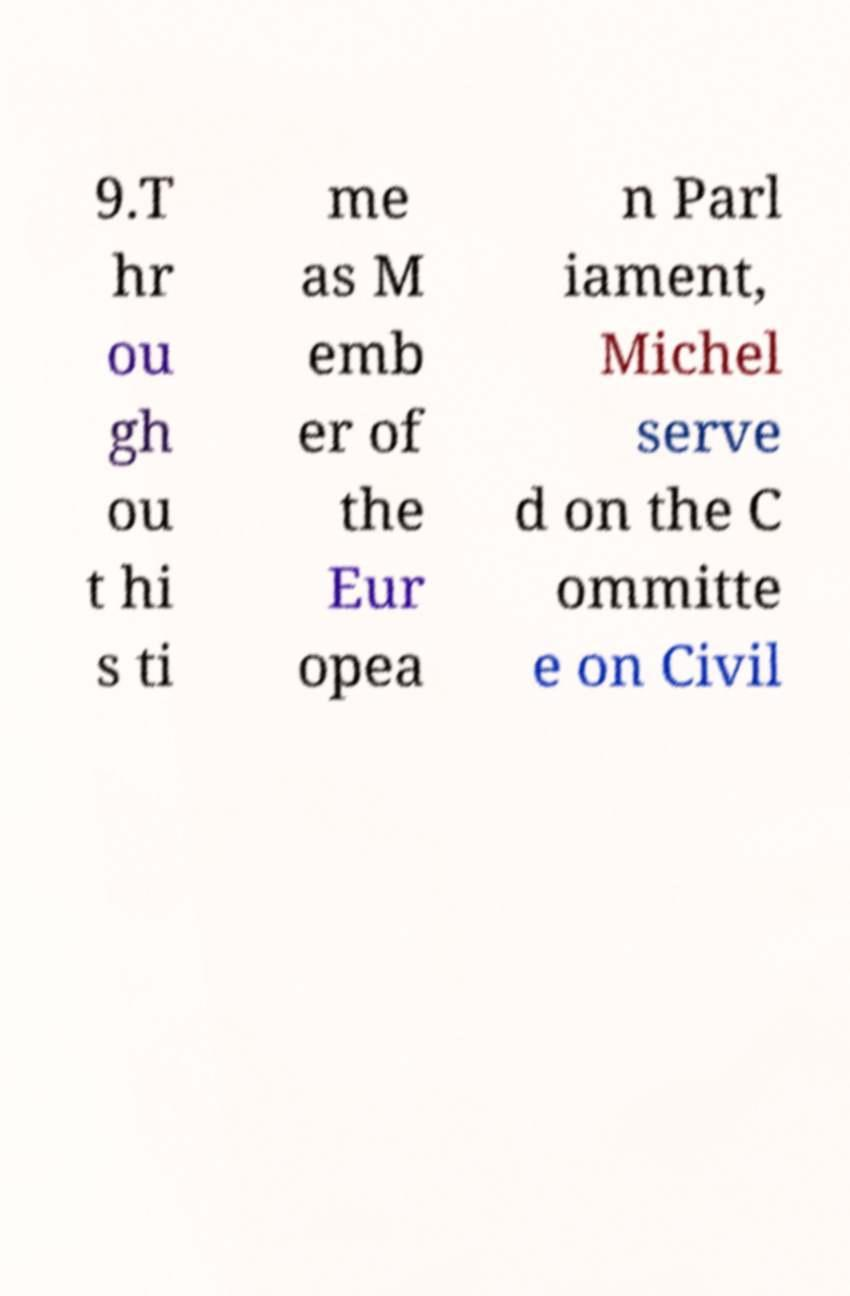What messages or text are displayed in this image? I need them in a readable, typed format. 9.T hr ou gh ou t hi s ti me as M emb er of the Eur opea n Parl iament, Michel serve d on the C ommitte e on Civil 